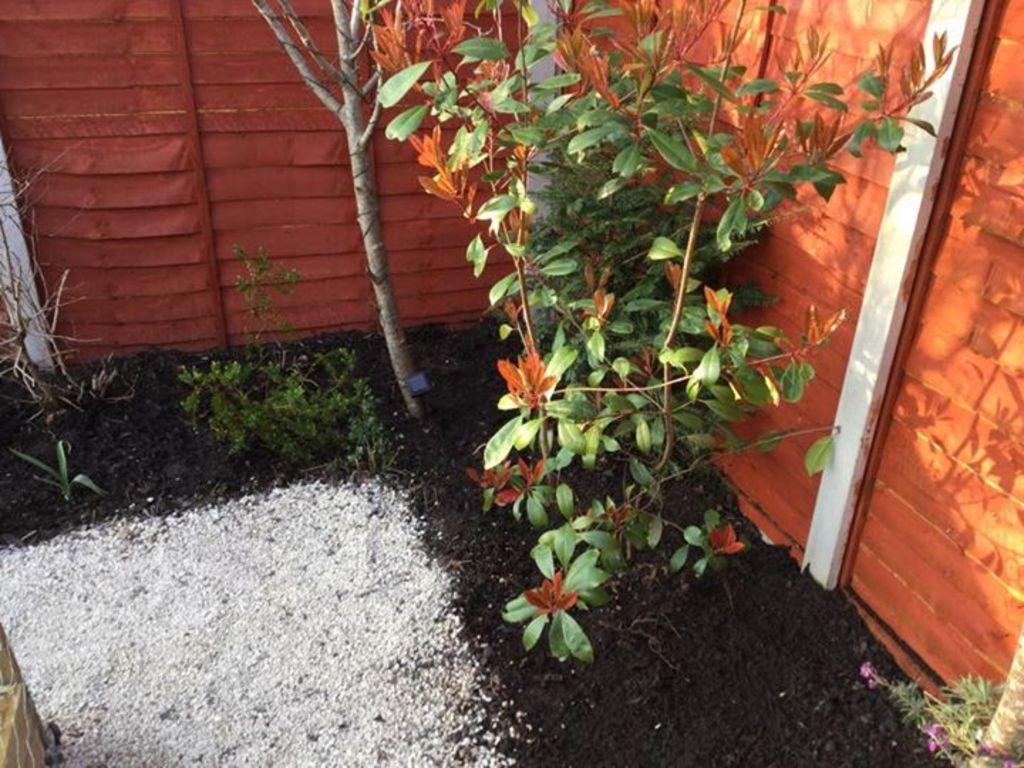What type of living organisms can be seen in the image? Plants can be seen in the image. What type of barrier is present in the image? There is a fence in the image. What type of terrain is visible in the image? There is mud and white-colored sand in the image. What type of attention is the sidewalk receiving in the image? There is no sidewalk present in the image. Can you describe the airplane's flight path in the image? There is no airplane present in the image. 